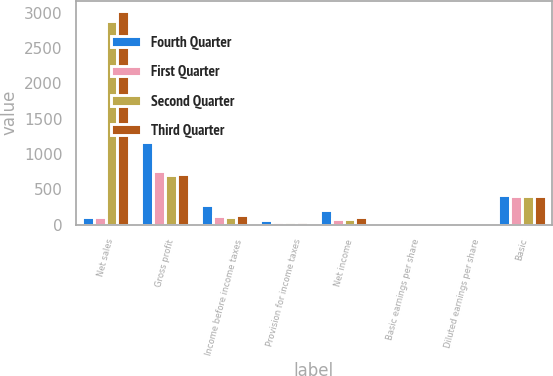Convert chart. <chart><loc_0><loc_0><loc_500><loc_500><stacked_bar_chart><ecel><fcel>Net sales<fcel>Gross profit<fcel>Income before income taxes<fcel>Provision for income taxes<fcel>Net income<fcel>Basic earnings per share<fcel>Diluted earnings per share<fcel>Basic<nl><fcel>Fourth Quarter<fcel>111<fcel>1170<fcel>281<fcel>74<fcel>207<fcel>0.5<fcel>0.48<fcel>416<nl><fcel>First Quarter<fcel>111<fcel>762<fcel>124<fcel>44<fcel>80<fcel>0.19<fcel>0.19<fcel>414<nl><fcel>Second Quarter<fcel>2886<fcel>701<fcel>111<fcel>33<fcel>78<fcel>0.19<fcel>0.19<fcel>412<nl><fcel>Third Quarter<fcel>3015<fcel>719<fcel>144<fcel>33<fcel>111<fcel>0.27<fcel>0.26<fcel>412<nl></chart> 